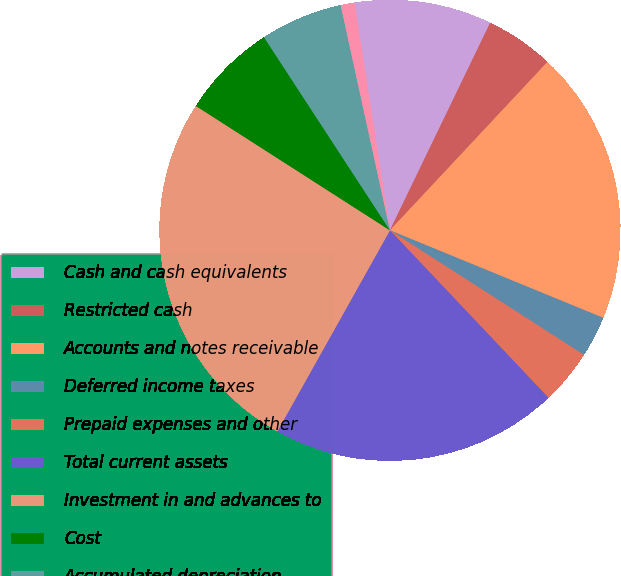Convert chart. <chart><loc_0><loc_0><loc_500><loc_500><pie_chart><fcel>Cash and cash equivalents<fcel>Restricted cash<fcel>Accounts and notes receivable<fcel>Deferred income taxes<fcel>Prepaid expenses and other<fcel>Total current assets<fcel>Investment in and advances to<fcel>Cost<fcel>Accumulated depreciation<fcel>Office equipment net<nl><fcel>9.62%<fcel>4.81%<fcel>19.23%<fcel>2.89%<fcel>3.85%<fcel>20.19%<fcel>25.95%<fcel>6.73%<fcel>5.77%<fcel>0.97%<nl></chart> 